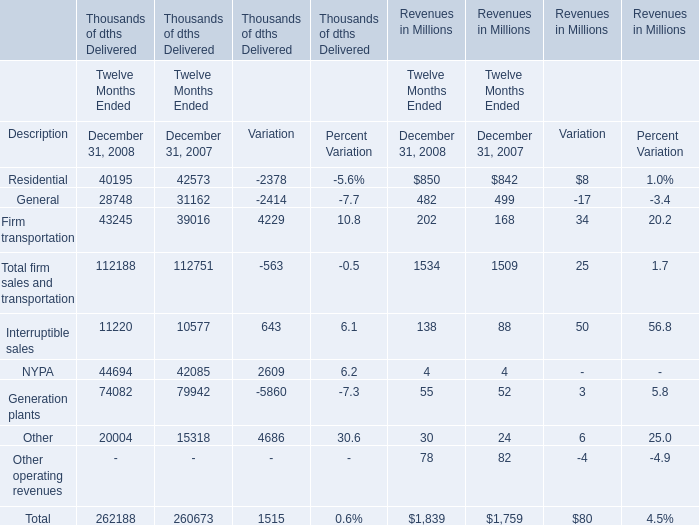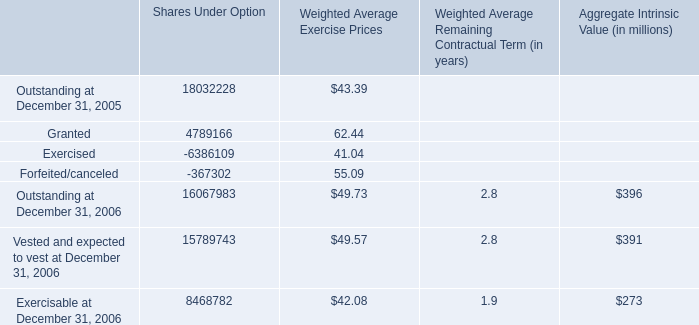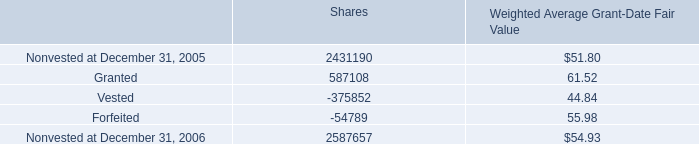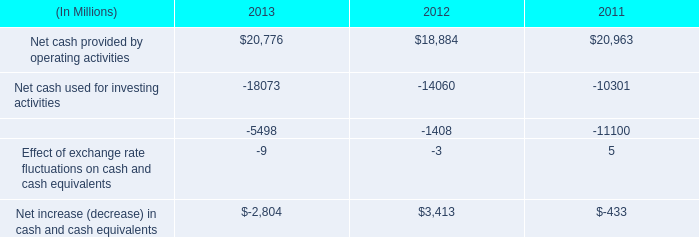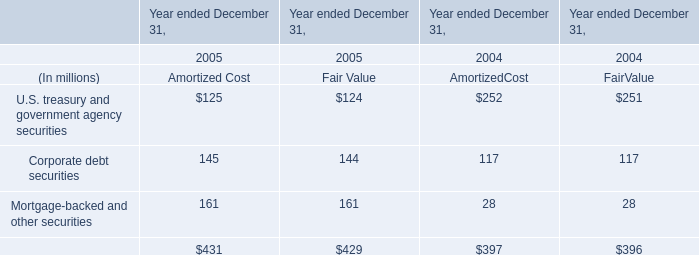What is the average amount of Forfeited/canceled of Shares Under Option, and Net cash provided by operating activities of 2013 ? 
Computations: ((367302.0 + 20776.0) / 2)
Answer: 194039.0. 